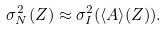Convert formula to latex. <formula><loc_0><loc_0><loc_500><loc_500>\sigma ^ { 2 } _ { N } ( Z ) \approx \sigma ^ { 2 } _ { I } ( \langle A \rangle ( Z ) ) .</formula> 